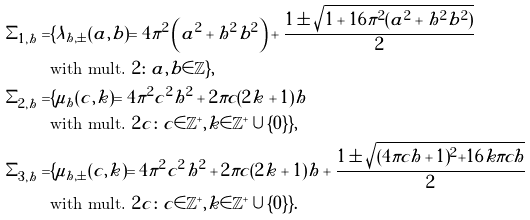<formula> <loc_0><loc_0><loc_500><loc_500>\Sigma _ { 1 , h } = & \{ \lambda _ { h , \pm } ( a , b ) = 4 \pi ^ { 2 } \left ( a ^ { 2 } + h ^ { 2 } b ^ { 2 } \right ) + \frac { 1 \pm \sqrt { 1 + 1 6 \pi ^ { 2 } ( a ^ { 2 } + h ^ { 2 } b ^ { 2 } ) } } { 2 } \\ & \text {with mult.} \ 2 \colon a , b \in \mathbb { Z } \} , \\ \Sigma _ { 2 , h } = & \{ \mu _ { h } ( c , k ) = 4 \pi ^ { 2 } c ^ { 2 } h ^ { 2 } + 2 \pi c ( 2 k + 1 ) h \\ & \text {with mult.} \ 2 c \colon c \in \mathbb { Z } ^ { + } , k \in \mathbb { Z } ^ { + } \cup \{ 0 \} \} , \\ \Sigma _ { 3 , h } = & \{ \mu _ { h , \pm } ( c , k ) = 4 \pi ^ { 2 } c ^ { 2 } h ^ { 2 } + 2 \pi c ( 2 k + 1 ) h + \frac { 1 \pm \sqrt { ( 4 \pi c h + 1 ) ^ { 2 } + 1 6 k \pi c h } } { 2 } \\ & \text {with mult.} \ 2 c \colon c \in \mathbb { Z } ^ { + } , k \in \mathbb { Z } ^ { + } \cup \{ 0 \} \} .</formula> 